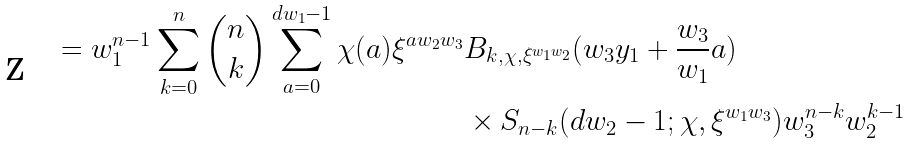<formula> <loc_0><loc_0><loc_500><loc_500>= w _ { 1 } ^ { n - 1 } \sum _ { k = 0 } ^ { n } \binom { n } { k } \sum _ { a = 0 } ^ { d w _ { 1 } - 1 } \chi ( a ) \xi ^ { a w _ { 2 } w _ { 3 } } & B _ { k , \chi , \xi ^ { w _ { 1 } w _ { 2 } } } ( w _ { 3 } y _ { 1 } + \frac { w _ { 3 } } { w _ { 1 } } a ) \\ & \times S _ { n - k } ( d w _ { 2 } - 1 ; \chi , \xi ^ { w _ { 1 } w _ { 3 } } ) w _ { 3 } ^ { n - k } w _ { 2 } ^ { k - 1 }</formula> 